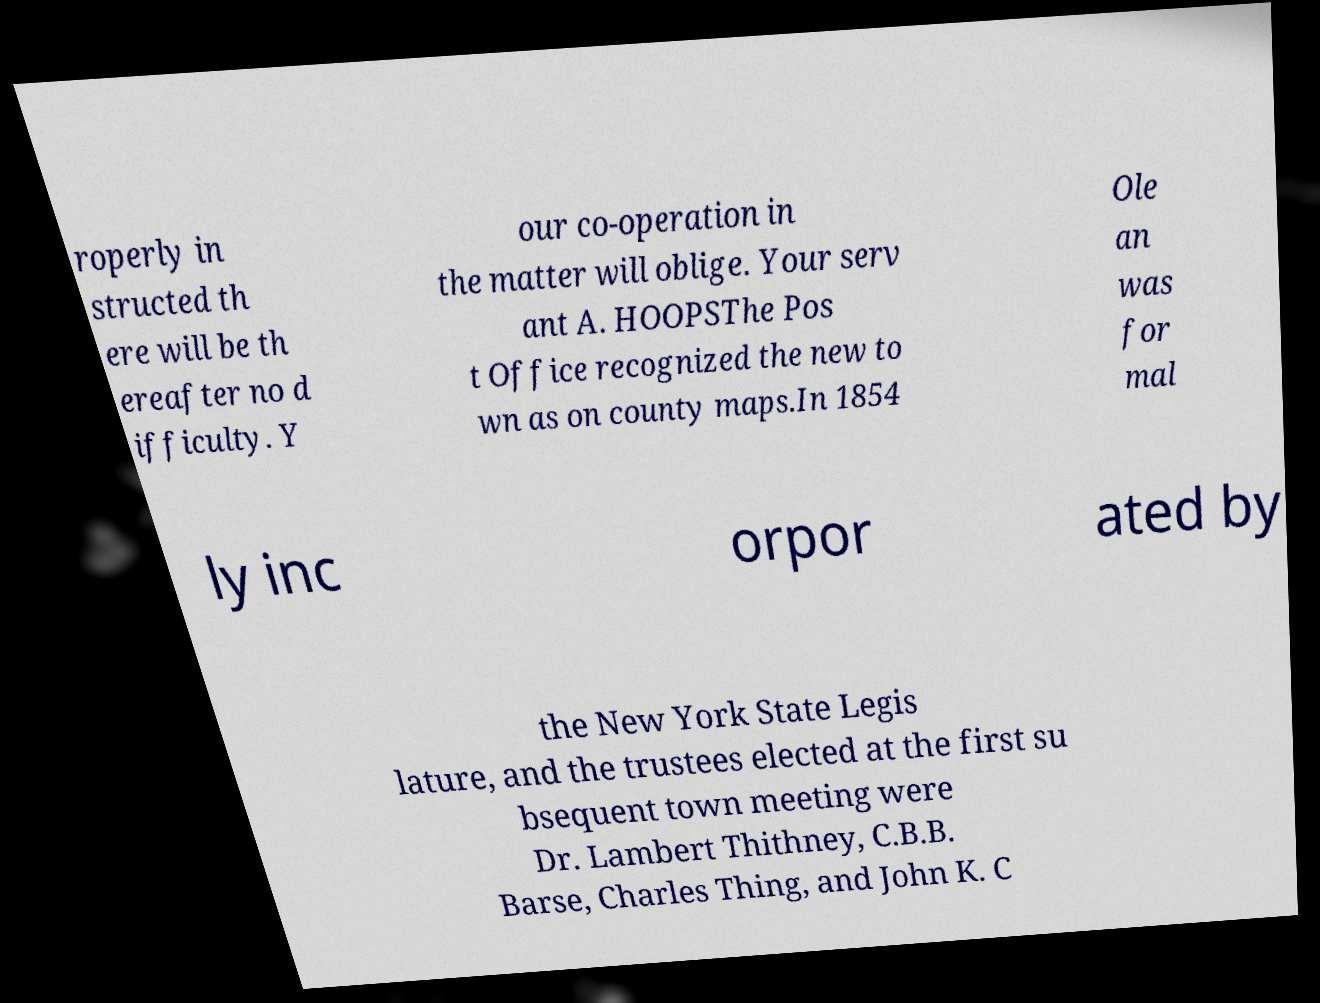Could you extract and type out the text from this image? roperly in structed th ere will be th ereafter no d ifficulty. Y our co-operation in the matter will oblige. Your serv ant A. HOOPSThe Pos t Office recognized the new to wn as on county maps.In 1854 Ole an was for mal ly inc orpor ated by the New York State Legis lature, and the trustees elected at the first su bsequent town meeting were Dr. Lambert Thithney, C.B.B. Barse, Charles Thing, and John K. C 